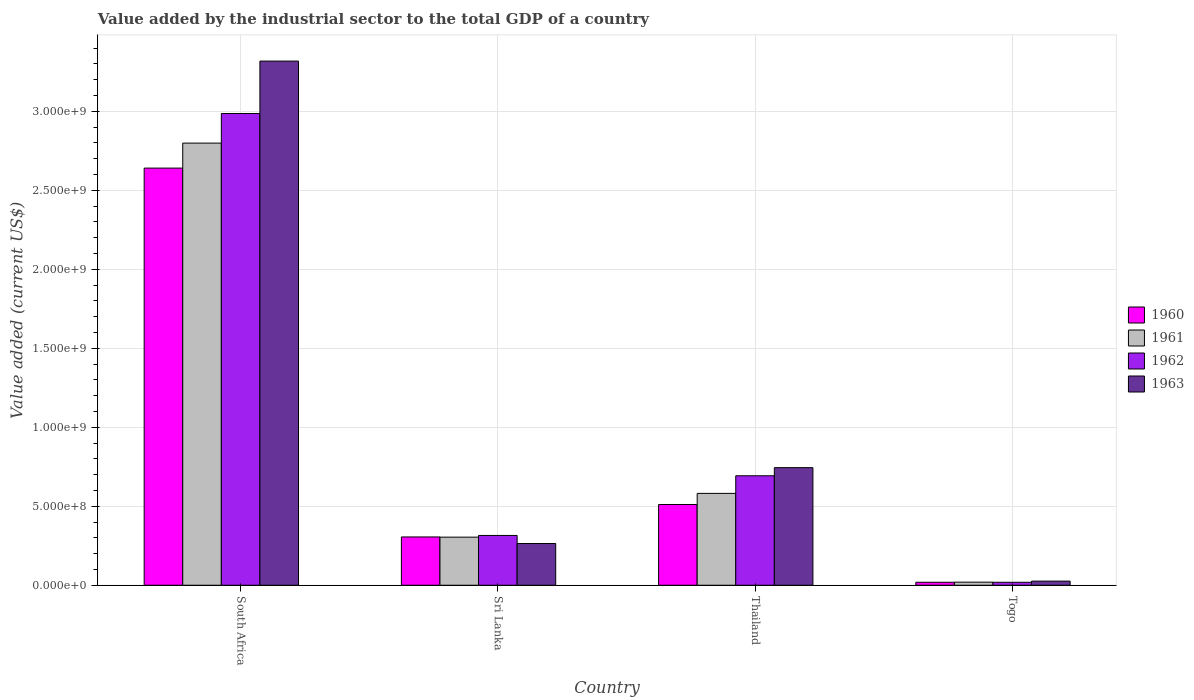How many different coloured bars are there?
Your response must be concise. 4. How many groups of bars are there?
Ensure brevity in your answer.  4. Are the number of bars on each tick of the X-axis equal?
Ensure brevity in your answer.  Yes. How many bars are there on the 2nd tick from the left?
Your response must be concise. 4. What is the label of the 4th group of bars from the left?
Your answer should be very brief. Togo. What is the value added by the industrial sector to the total GDP in 1962 in Thailand?
Ensure brevity in your answer.  6.93e+08. Across all countries, what is the maximum value added by the industrial sector to the total GDP in 1962?
Make the answer very short. 2.99e+09. Across all countries, what is the minimum value added by the industrial sector to the total GDP in 1961?
Your response must be concise. 1.96e+07. In which country was the value added by the industrial sector to the total GDP in 1963 maximum?
Provide a short and direct response. South Africa. In which country was the value added by the industrial sector to the total GDP in 1963 minimum?
Ensure brevity in your answer.  Togo. What is the total value added by the industrial sector to the total GDP in 1961 in the graph?
Provide a succinct answer. 3.70e+09. What is the difference between the value added by the industrial sector to the total GDP in 1963 in South Africa and that in Togo?
Give a very brief answer. 3.29e+09. What is the difference between the value added by the industrial sector to the total GDP in 1963 in Togo and the value added by the industrial sector to the total GDP in 1961 in Thailand?
Offer a very short reply. -5.55e+08. What is the average value added by the industrial sector to the total GDP in 1963 per country?
Keep it short and to the point. 1.09e+09. What is the difference between the value added by the industrial sector to the total GDP of/in 1961 and value added by the industrial sector to the total GDP of/in 1962 in Sri Lanka?
Offer a very short reply. -1.08e+07. In how many countries, is the value added by the industrial sector to the total GDP in 1962 greater than 2300000000 US$?
Ensure brevity in your answer.  1. What is the ratio of the value added by the industrial sector to the total GDP in 1961 in South Africa to that in Sri Lanka?
Your answer should be very brief. 9.19. Is the value added by the industrial sector to the total GDP in 1963 in Sri Lanka less than that in Togo?
Provide a short and direct response. No. Is the difference between the value added by the industrial sector to the total GDP in 1961 in South Africa and Sri Lanka greater than the difference between the value added by the industrial sector to the total GDP in 1962 in South Africa and Sri Lanka?
Ensure brevity in your answer.  No. What is the difference between the highest and the second highest value added by the industrial sector to the total GDP in 1962?
Keep it short and to the point. -3.78e+08. What is the difference between the highest and the lowest value added by the industrial sector to the total GDP in 1961?
Make the answer very short. 2.78e+09. Is the sum of the value added by the industrial sector to the total GDP in 1961 in South Africa and Sri Lanka greater than the maximum value added by the industrial sector to the total GDP in 1960 across all countries?
Your answer should be compact. Yes. What does the 2nd bar from the right in Sri Lanka represents?
Give a very brief answer. 1962. Are all the bars in the graph horizontal?
Your answer should be very brief. No. How many countries are there in the graph?
Your response must be concise. 4. What is the difference between two consecutive major ticks on the Y-axis?
Provide a short and direct response. 5.00e+08. Are the values on the major ticks of Y-axis written in scientific E-notation?
Offer a very short reply. Yes. Does the graph contain grids?
Give a very brief answer. Yes. How many legend labels are there?
Ensure brevity in your answer.  4. What is the title of the graph?
Ensure brevity in your answer.  Value added by the industrial sector to the total GDP of a country. What is the label or title of the X-axis?
Your answer should be compact. Country. What is the label or title of the Y-axis?
Ensure brevity in your answer.  Value added (current US$). What is the Value added (current US$) of 1960 in South Africa?
Provide a short and direct response. 2.64e+09. What is the Value added (current US$) of 1961 in South Africa?
Offer a terse response. 2.80e+09. What is the Value added (current US$) of 1962 in South Africa?
Your answer should be very brief. 2.99e+09. What is the Value added (current US$) in 1963 in South Africa?
Your answer should be very brief. 3.32e+09. What is the Value added (current US$) of 1960 in Sri Lanka?
Provide a short and direct response. 3.06e+08. What is the Value added (current US$) of 1961 in Sri Lanka?
Provide a succinct answer. 3.04e+08. What is the Value added (current US$) in 1962 in Sri Lanka?
Provide a succinct answer. 3.15e+08. What is the Value added (current US$) of 1963 in Sri Lanka?
Your answer should be very brief. 2.64e+08. What is the Value added (current US$) in 1960 in Thailand?
Your answer should be very brief. 5.11e+08. What is the Value added (current US$) in 1961 in Thailand?
Offer a very short reply. 5.81e+08. What is the Value added (current US$) in 1962 in Thailand?
Your answer should be very brief. 6.93e+08. What is the Value added (current US$) of 1963 in Thailand?
Provide a short and direct response. 7.44e+08. What is the Value added (current US$) in 1960 in Togo?
Your response must be concise. 1.88e+07. What is the Value added (current US$) of 1961 in Togo?
Offer a very short reply. 1.96e+07. What is the Value added (current US$) of 1962 in Togo?
Provide a short and direct response. 1.88e+07. What is the Value added (current US$) in 1963 in Togo?
Your answer should be compact. 2.61e+07. Across all countries, what is the maximum Value added (current US$) in 1960?
Your answer should be compact. 2.64e+09. Across all countries, what is the maximum Value added (current US$) in 1961?
Give a very brief answer. 2.80e+09. Across all countries, what is the maximum Value added (current US$) of 1962?
Your answer should be very brief. 2.99e+09. Across all countries, what is the maximum Value added (current US$) of 1963?
Your response must be concise. 3.32e+09. Across all countries, what is the minimum Value added (current US$) in 1960?
Your response must be concise. 1.88e+07. Across all countries, what is the minimum Value added (current US$) in 1961?
Give a very brief answer. 1.96e+07. Across all countries, what is the minimum Value added (current US$) in 1962?
Make the answer very short. 1.88e+07. Across all countries, what is the minimum Value added (current US$) in 1963?
Your answer should be very brief. 2.61e+07. What is the total Value added (current US$) of 1960 in the graph?
Provide a succinct answer. 3.48e+09. What is the total Value added (current US$) of 1961 in the graph?
Offer a very short reply. 3.70e+09. What is the total Value added (current US$) of 1962 in the graph?
Offer a very short reply. 4.01e+09. What is the total Value added (current US$) of 1963 in the graph?
Keep it short and to the point. 4.35e+09. What is the difference between the Value added (current US$) in 1960 in South Africa and that in Sri Lanka?
Offer a terse response. 2.33e+09. What is the difference between the Value added (current US$) of 1961 in South Africa and that in Sri Lanka?
Your response must be concise. 2.49e+09. What is the difference between the Value added (current US$) in 1962 in South Africa and that in Sri Lanka?
Your answer should be compact. 2.67e+09. What is the difference between the Value added (current US$) of 1963 in South Africa and that in Sri Lanka?
Keep it short and to the point. 3.05e+09. What is the difference between the Value added (current US$) in 1960 in South Africa and that in Thailand?
Your answer should be very brief. 2.13e+09. What is the difference between the Value added (current US$) of 1961 in South Africa and that in Thailand?
Give a very brief answer. 2.22e+09. What is the difference between the Value added (current US$) in 1962 in South Africa and that in Thailand?
Your answer should be compact. 2.29e+09. What is the difference between the Value added (current US$) of 1963 in South Africa and that in Thailand?
Your answer should be very brief. 2.57e+09. What is the difference between the Value added (current US$) in 1960 in South Africa and that in Togo?
Provide a short and direct response. 2.62e+09. What is the difference between the Value added (current US$) in 1961 in South Africa and that in Togo?
Keep it short and to the point. 2.78e+09. What is the difference between the Value added (current US$) in 1962 in South Africa and that in Togo?
Give a very brief answer. 2.97e+09. What is the difference between the Value added (current US$) of 1963 in South Africa and that in Togo?
Keep it short and to the point. 3.29e+09. What is the difference between the Value added (current US$) in 1960 in Sri Lanka and that in Thailand?
Make the answer very short. -2.06e+08. What is the difference between the Value added (current US$) of 1961 in Sri Lanka and that in Thailand?
Your answer should be compact. -2.77e+08. What is the difference between the Value added (current US$) of 1962 in Sri Lanka and that in Thailand?
Ensure brevity in your answer.  -3.78e+08. What is the difference between the Value added (current US$) in 1963 in Sri Lanka and that in Thailand?
Offer a very short reply. -4.80e+08. What is the difference between the Value added (current US$) in 1960 in Sri Lanka and that in Togo?
Your answer should be compact. 2.87e+08. What is the difference between the Value added (current US$) of 1961 in Sri Lanka and that in Togo?
Provide a short and direct response. 2.85e+08. What is the difference between the Value added (current US$) in 1962 in Sri Lanka and that in Togo?
Offer a terse response. 2.96e+08. What is the difference between the Value added (current US$) of 1963 in Sri Lanka and that in Togo?
Your answer should be very brief. 2.38e+08. What is the difference between the Value added (current US$) of 1960 in Thailand and that in Togo?
Your answer should be compact. 4.92e+08. What is the difference between the Value added (current US$) of 1961 in Thailand and that in Togo?
Your response must be concise. 5.62e+08. What is the difference between the Value added (current US$) of 1962 in Thailand and that in Togo?
Provide a succinct answer. 6.74e+08. What is the difference between the Value added (current US$) in 1963 in Thailand and that in Togo?
Provide a succinct answer. 7.18e+08. What is the difference between the Value added (current US$) of 1960 in South Africa and the Value added (current US$) of 1961 in Sri Lanka?
Provide a succinct answer. 2.34e+09. What is the difference between the Value added (current US$) in 1960 in South Africa and the Value added (current US$) in 1962 in Sri Lanka?
Provide a short and direct response. 2.33e+09. What is the difference between the Value added (current US$) in 1960 in South Africa and the Value added (current US$) in 1963 in Sri Lanka?
Give a very brief answer. 2.38e+09. What is the difference between the Value added (current US$) of 1961 in South Africa and the Value added (current US$) of 1962 in Sri Lanka?
Keep it short and to the point. 2.48e+09. What is the difference between the Value added (current US$) in 1961 in South Africa and the Value added (current US$) in 1963 in Sri Lanka?
Ensure brevity in your answer.  2.53e+09. What is the difference between the Value added (current US$) of 1962 in South Africa and the Value added (current US$) of 1963 in Sri Lanka?
Provide a succinct answer. 2.72e+09. What is the difference between the Value added (current US$) in 1960 in South Africa and the Value added (current US$) in 1961 in Thailand?
Offer a very short reply. 2.06e+09. What is the difference between the Value added (current US$) of 1960 in South Africa and the Value added (current US$) of 1962 in Thailand?
Provide a short and direct response. 1.95e+09. What is the difference between the Value added (current US$) of 1960 in South Africa and the Value added (current US$) of 1963 in Thailand?
Keep it short and to the point. 1.90e+09. What is the difference between the Value added (current US$) in 1961 in South Africa and the Value added (current US$) in 1962 in Thailand?
Give a very brief answer. 2.11e+09. What is the difference between the Value added (current US$) in 1961 in South Africa and the Value added (current US$) in 1963 in Thailand?
Your answer should be compact. 2.05e+09. What is the difference between the Value added (current US$) in 1962 in South Africa and the Value added (current US$) in 1963 in Thailand?
Offer a very short reply. 2.24e+09. What is the difference between the Value added (current US$) of 1960 in South Africa and the Value added (current US$) of 1961 in Togo?
Offer a very short reply. 2.62e+09. What is the difference between the Value added (current US$) in 1960 in South Africa and the Value added (current US$) in 1962 in Togo?
Provide a succinct answer. 2.62e+09. What is the difference between the Value added (current US$) in 1960 in South Africa and the Value added (current US$) in 1963 in Togo?
Offer a very short reply. 2.61e+09. What is the difference between the Value added (current US$) of 1961 in South Africa and the Value added (current US$) of 1962 in Togo?
Your answer should be very brief. 2.78e+09. What is the difference between the Value added (current US$) of 1961 in South Africa and the Value added (current US$) of 1963 in Togo?
Make the answer very short. 2.77e+09. What is the difference between the Value added (current US$) in 1962 in South Africa and the Value added (current US$) in 1963 in Togo?
Ensure brevity in your answer.  2.96e+09. What is the difference between the Value added (current US$) of 1960 in Sri Lanka and the Value added (current US$) of 1961 in Thailand?
Ensure brevity in your answer.  -2.76e+08. What is the difference between the Value added (current US$) of 1960 in Sri Lanka and the Value added (current US$) of 1962 in Thailand?
Keep it short and to the point. -3.87e+08. What is the difference between the Value added (current US$) in 1960 in Sri Lanka and the Value added (current US$) in 1963 in Thailand?
Provide a short and direct response. -4.39e+08. What is the difference between the Value added (current US$) of 1961 in Sri Lanka and the Value added (current US$) of 1962 in Thailand?
Keep it short and to the point. -3.89e+08. What is the difference between the Value added (current US$) of 1961 in Sri Lanka and the Value added (current US$) of 1963 in Thailand?
Your answer should be very brief. -4.40e+08. What is the difference between the Value added (current US$) of 1962 in Sri Lanka and the Value added (current US$) of 1963 in Thailand?
Provide a short and direct response. -4.29e+08. What is the difference between the Value added (current US$) in 1960 in Sri Lanka and the Value added (current US$) in 1961 in Togo?
Your answer should be very brief. 2.86e+08. What is the difference between the Value added (current US$) of 1960 in Sri Lanka and the Value added (current US$) of 1962 in Togo?
Provide a succinct answer. 2.87e+08. What is the difference between the Value added (current US$) of 1960 in Sri Lanka and the Value added (current US$) of 1963 in Togo?
Ensure brevity in your answer.  2.80e+08. What is the difference between the Value added (current US$) in 1961 in Sri Lanka and the Value added (current US$) in 1962 in Togo?
Give a very brief answer. 2.86e+08. What is the difference between the Value added (current US$) in 1961 in Sri Lanka and the Value added (current US$) in 1963 in Togo?
Offer a terse response. 2.78e+08. What is the difference between the Value added (current US$) in 1962 in Sri Lanka and the Value added (current US$) in 1963 in Togo?
Ensure brevity in your answer.  2.89e+08. What is the difference between the Value added (current US$) of 1960 in Thailand and the Value added (current US$) of 1961 in Togo?
Ensure brevity in your answer.  4.92e+08. What is the difference between the Value added (current US$) in 1960 in Thailand and the Value added (current US$) in 1962 in Togo?
Make the answer very short. 4.92e+08. What is the difference between the Value added (current US$) of 1960 in Thailand and the Value added (current US$) of 1963 in Togo?
Ensure brevity in your answer.  4.85e+08. What is the difference between the Value added (current US$) of 1961 in Thailand and the Value added (current US$) of 1962 in Togo?
Offer a terse response. 5.63e+08. What is the difference between the Value added (current US$) of 1961 in Thailand and the Value added (current US$) of 1963 in Togo?
Give a very brief answer. 5.55e+08. What is the difference between the Value added (current US$) in 1962 in Thailand and the Value added (current US$) in 1963 in Togo?
Your answer should be very brief. 6.67e+08. What is the average Value added (current US$) in 1960 per country?
Provide a succinct answer. 8.69e+08. What is the average Value added (current US$) in 1961 per country?
Provide a short and direct response. 9.26e+08. What is the average Value added (current US$) in 1962 per country?
Provide a succinct answer. 1.00e+09. What is the average Value added (current US$) of 1963 per country?
Offer a very short reply. 1.09e+09. What is the difference between the Value added (current US$) of 1960 and Value added (current US$) of 1961 in South Africa?
Your answer should be compact. -1.58e+08. What is the difference between the Value added (current US$) in 1960 and Value added (current US$) in 1962 in South Africa?
Ensure brevity in your answer.  -3.46e+08. What is the difference between the Value added (current US$) of 1960 and Value added (current US$) of 1963 in South Africa?
Offer a very short reply. -6.78e+08. What is the difference between the Value added (current US$) in 1961 and Value added (current US$) in 1962 in South Africa?
Make the answer very short. -1.87e+08. What is the difference between the Value added (current US$) in 1961 and Value added (current US$) in 1963 in South Africa?
Make the answer very short. -5.19e+08. What is the difference between the Value added (current US$) in 1962 and Value added (current US$) in 1963 in South Africa?
Make the answer very short. -3.32e+08. What is the difference between the Value added (current US$) of 1960 and Value added (current US$) of 1961 in Sri Lanka?
Make the answer very short. 1.26e+06. What is the difference between the Value added (current US$) in 1960 and Value added (current US$) in 1962 in Sri Lanka?
Ensure brevity in your answer.  -9.55e+06. What is the difference between the Value added (current US$) in 1960 and Value added (current US$) in 1963 in Sri Lanka?
Ensure brevity in your answer.  4.16e+07. What is the difference between the Value added (current US$) in 1961 and Value added (current US$) in 1962 in Sri Lanka?
Provide a succinct answer. -1.08e+07. What is the difference between the Value added (current US$) of 1961 and Value added (current US$) of 1963 in Sri Lanka?
Offer a terse response. 4.04e+07. What is the difference between the Value added (current US$) of 1962 and Value added (current US$) of 1963 in Sri Lanka?
Give a very brief answer. 5.12e+07. What is the difference between the Value added (current US$) of 1960 and Value added (current US$) of 1961 in Thailand?
Offer a terse response. -7.03e+07. What is the difference between the Value added (current US$) of 1960 and Value added (current US$) of 1962 in Thailand?
Provide a succinct answer. -1.82e+08. What is the difference between the Value added (current US$) in 1960 and Value added (current US$) in 1963 in Thailand?
Provide a succinct answer. -2.33e+08. What is the difference between the Value added (current US$) of 1961 and Value added (current US$) of 1962 in Thailand?
Your answer should be very brief. -1.12e+08. What is the difference between the Value added (current US$) in 1961 and Value added (current US$) in 1963 in Thailand?
Provide a succinct answer. -1.63e+08. What is the difference between the Value added (current US$) of 1962 and Value added (current US$) of 1963 in Thailand?
Offer a terse response. -5.15e+07. What is the difference between the Value added (current US$) of 1960 and Value added (current US$) of 1961 in Togo?
Ensure brevity in your answer.  -8.10e+05. What is the difference between the Value added (current US$) of 1960 and Value added (current US$) of 1962 in Togo?
Offer a terse response. -1.39e+04. What is the difference between the Value added (current US$) of 1960 and Value added (current US$) of 1963 in Togo?
Your answer should be compact. -7.36e+06. What is the difference between the Value added (current US$) of 1961 and Value added (current US$) of 1962 in Togo?
Provide a short and direct response. 7.97e+05. What is the difference between the Value added (current US$) in 1961 and Value added (current US$) in 1963 in Togo?
Offer a very short reply. -6.55e+06. What is the difference between the Value added (current US$) of 1962 and Value added (current US$) of 1963 in Togo?
Your answer should be very brief. -7.35e+06. What is the ratio of the Value added (current US$) of 1960 in South Africa to that in Sri Lanka?
Offer a very short reply. 8.64. What is the ratio of the Value added (current US$) of 1961 in South Africa to that in Sri Lanka?
Your response must be concise. 9.19. What is the ratio of the Value added (current US$) in 1962 in South Africa to that in Sri Lanka?
Provide a succinct answer. 9.47. What is the ratio of the Value added (current US$) in 1963 in South Africa to that in Sri Lanka?
Ensure brevity in your answer.  12.57. What is the ratio of the Value added (current US$) of 1960 in South Africa to that in Thailand?
Offer a terse response. 5.17. What is the ratio of the Value added (current US$) in 1961 in South Africa to that in Thailand?
Give a very brief answer. 4.81. What is the ratio of the Value added (current US$) of 1962 in South Africa to that in Thailand?
Provide a succinct answer. 4.31. What is the ratio of the Value added (current US$) of 1963 in South Africa to that in Thailand?
Your response must be concise. 4.46. What is the ratio of the Value added (current US$) of 1960 in South Africa to that in Togo?
Your response must be concise. 140.76. What is the ratio of the Value added (current US$) in 1961 in South Africa to that in Togo?
Your answer should be compact. 143.01. What is the ratio of the Value added (current US$) of 1962 in South Africa to that in Togo?
Provide a succinct answer. 159.06. What is the ratio of the Value added (current US$) of 1963 in South Africa to that in Togo?
Make the answer very short. 127.03. What is the ratio of the Value added (current US$) of 1960 in Sri Lanka to that in Thailand?
Your response must be concise. 0.6. What is the ratio of the Value added (current US$) of 1961 in Sri Lanka to that in Thailand?
Make the answer very short. 0.52. What is the ratio of the Value added (current US$) in 1962 in Sri Lanka to that in Thailand?
Your answer should be very brief. 0.45. What is the ratio of the Value added (current US$) of 1963 in Sri Lanka to that in Thailand?
Provide a short and direct response. 0.35. What is the ratio of the Value added (current US$) in 1960 in Sri Lanka to that in Togo?
Your answer should be compact. 16.29. What is the ratio of the Value added (current US$) of 1961 in Sri Lanka to that in Togo?
Offer a very short reply. 15.55. What is the ratio of the Value added (current US$) in 1962 in Sri Lanka to that in Togo?
Provide a succinct answer. 16.79. What is the ratio of the Value added (current US$) of 1963 in Sri Lanka to that in Togo?
Ensure brevity in your answer.  10.11. What is the ratio of the Value added (current US$) of 1960 in Thailand to that in Togo?
Provide a succinct answer. 27.25. What is the ratio of the Value added (current US$) of 1961 in Thailand to that in Togo?
Provide a succinct answer. 29.71. What is the ratio of the Value added (current US$) in 1962 in Thailand to that in Togo?
Your answer should be compact. 36.91. What is the difference between the highest and the second highest Value added (current US$) in 1960?
Offer a very short reply. 2.13e+09. What is the difference between the highest and the second highest Value added (current US$) in 1961?
Offer a terse response. 2.22e+09. What is the difference between the highest and the second highest Value added (current US$) in 1962?
Make the answer very short. 2.29e+09. What is the difference between the highest and the second highest Value added (current US$) of 1963?
Your answer should be very brief. 2.57e+09. What is the difference between the highest and the lowest Value added (current US$) of 1960?
Make the answer very short. 2.62e+09. What is the difference between the highest and the lowest Value added (current US$) of 1961?
Your answer should be compact. 2.78e+09. What is the difference between the highest and the lowest Value added (current US$) of 1962?
Your response must be concise. 2.97e+09. What is the difference between the highest and the lowest Value added (current US$) in 1963?
Make the answer very short. 3.29e+09. 